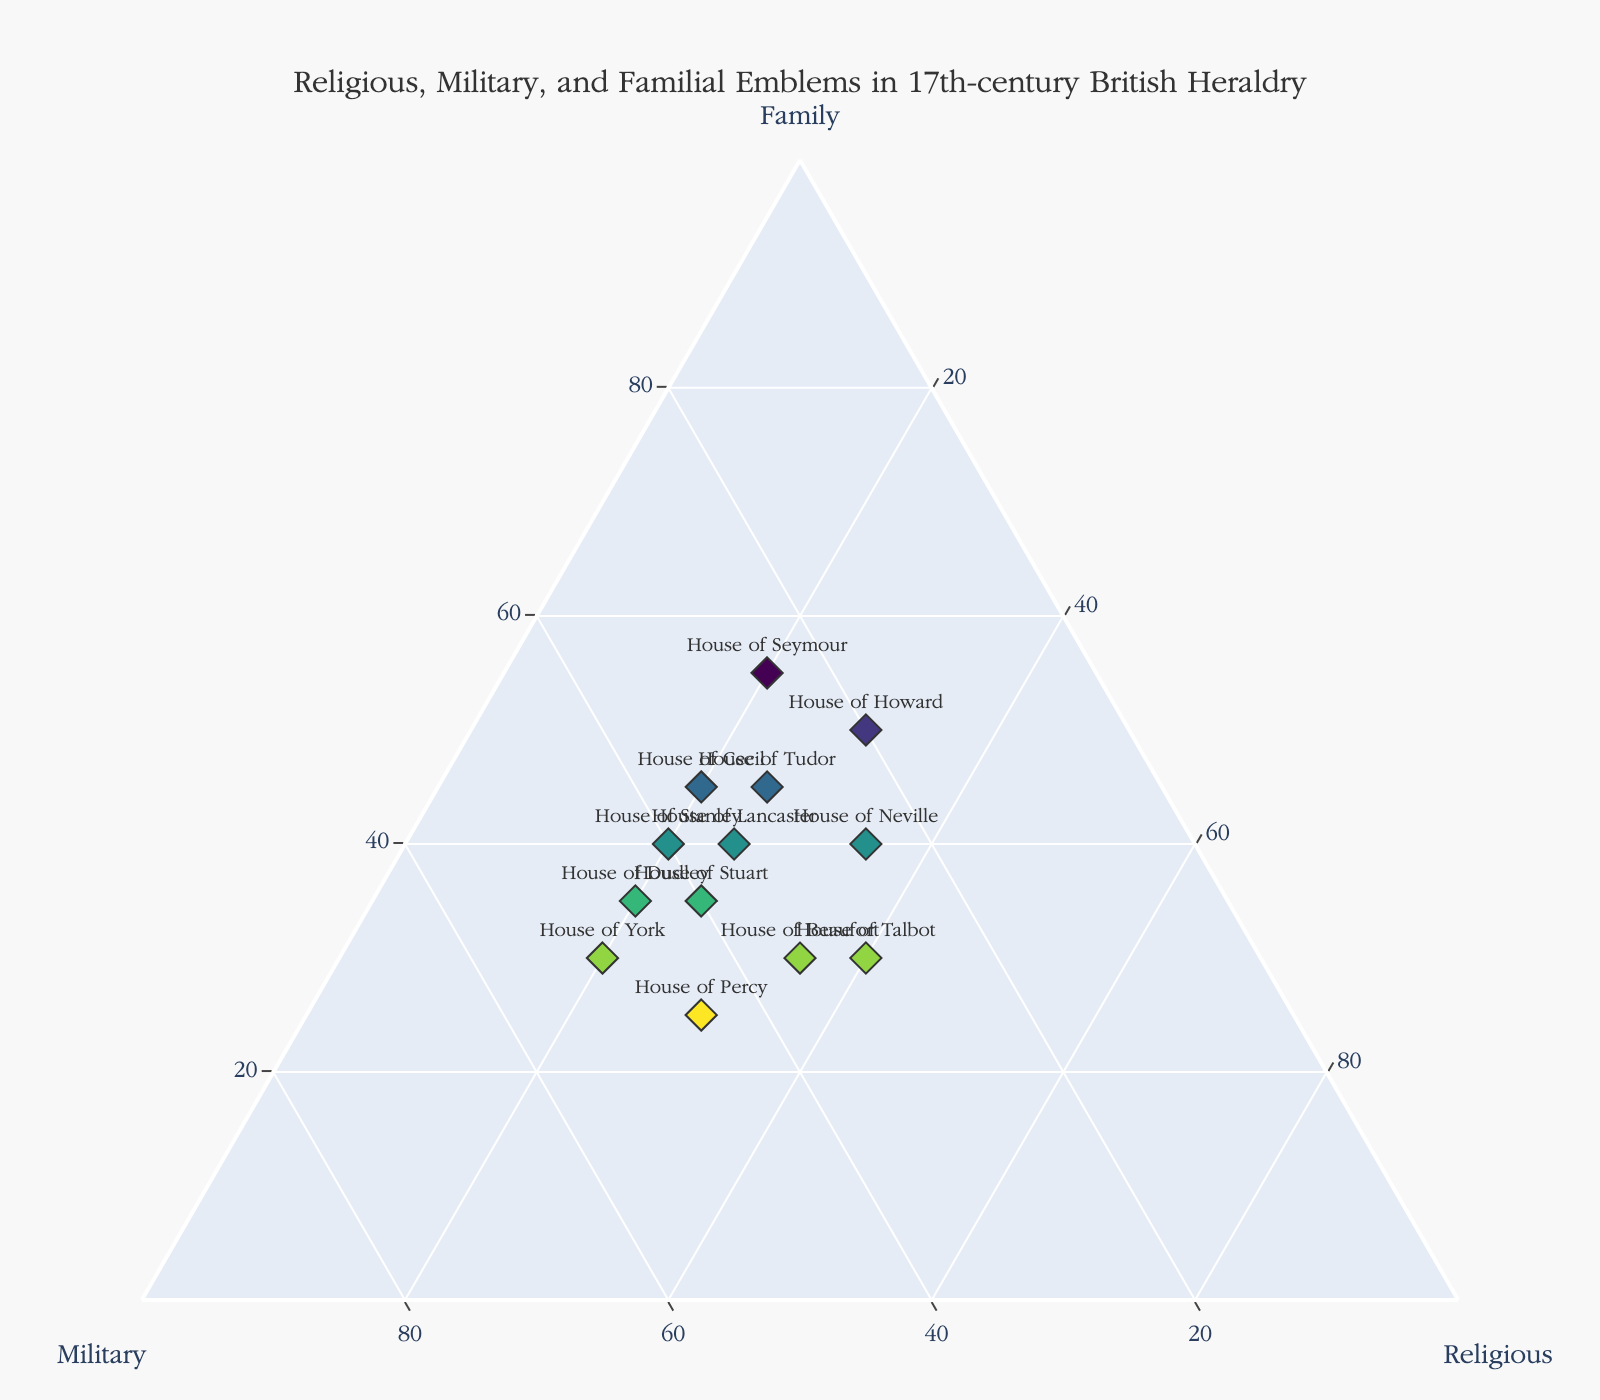What's the title of the figure? The title is usually displayed at the top of the figure, providing the main context or topic. In this case, it is directly mentioned in the code as part of the plot's layout.
Answer: Religious, Military, and Familial Emblems in 17th-century British Heraldry Which house places the highest emphasis on familial emblems? The value in the 'Family' axis represents the emphasis on familial emblems. The house with the highest value in this axis is the one most focused on this aspect.
Answer: House of Seymour How many houses feature more military emblems than religious emblems? By comparing the 'Military' and 'Religious' values for each house, we count how many times the 'Military' value is greater.
Answer: 9 What is the average prevalence of religious emblems across all houses? Sum all 'Religious' values and divide by the number of houses. The provided data includes 13 houses. Sum: 25+20+25+25+30+30+35+35+20+20+20+40+20 = 345; Average: 345/13
Answer: 26.54 Which house has an equal prevalence of familial and military emblems? Look for data points where the 'Family' and 'Military' values are equal. From the data, this happens at House of Stanley, as both values are 40.
Answer: House of Stanley Overall, which type of emblem has the highest single-house representation, and what is the value? Identify the highest value in 'Family', 'Military', and 'Religious' columns. The highest single value among all this occurs in the 'Family' column for the House of Seymour at 55.
Answer: Family, 55 Which house ranks the highest in religious emblems? Examine the 'Religious' column and determine which house has the highest value. The highest prevalence for 'Religious' emblems is found in House of Talbot with a value of 40.
Answer: House of Talbot Which two houses have the closest proportional distribution of emblems? By observing the ternary plot, identify points that are aesthetically closest to each other, indicating similar proportions. A closer check of specific values can include Houses with similar coordinates like House of Lancaster (40,35,25) and House of Tudor (45,30,25).
Answer: House of Lancaster and House of Tudor 